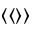Convert formula to latex. <formula><loc_0><loc_0><loc_500><loc_500>\langle \langle \rangle \rangle</formula> 